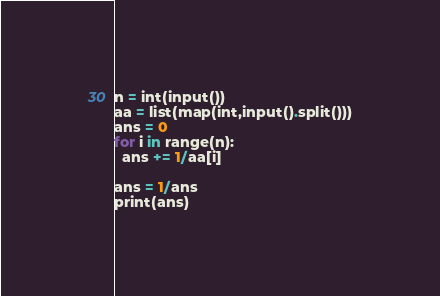<code> <loc_0><loc_0><loc_500><loc_500><_Python_>n = int(input())
aa = list(map(int,input().split()))
ans = 0
for i in range(n):
  ans += 1/aa[i]

ans = 1/ans
print(ans)  </code> 